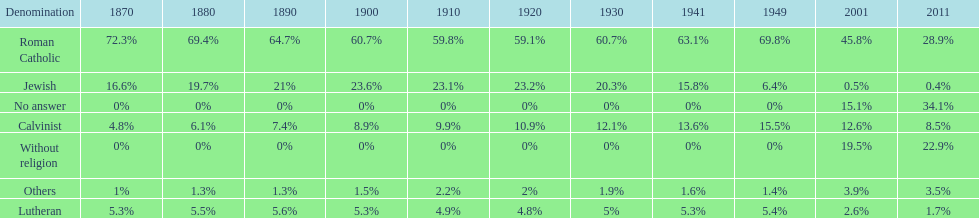The percentage of people who identified as calvinist was, at most, how much? 15.5%. 